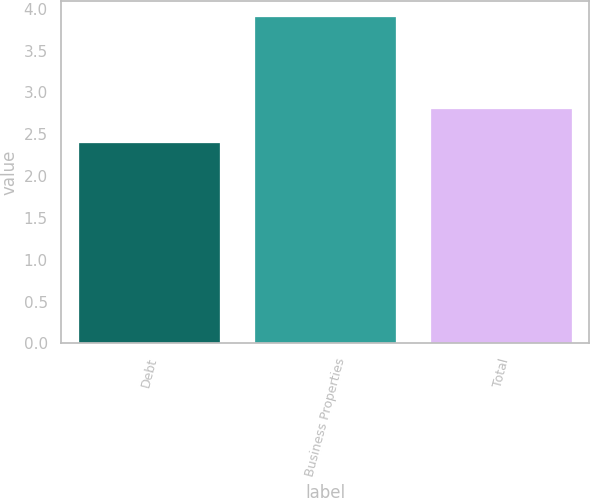Convert chart. <chart><loc_0><loc_0><loc_500><loc_500><bar_chart><fcel>Debt<fcel>Business Properties<fcel>Total<nl><fcel>2.4<fcel>3.9<fcel>2.8<nl></chart> 